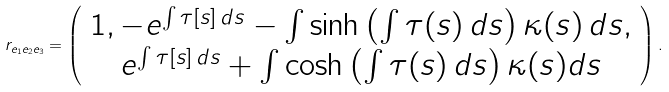Convert formula to latex. <formula><loc_0><loc_0><loc_500><loc_500>r _ { e _ { 1 } e _ { 2 } e _ { 3 } } = \left ( \begin{array} { c } 1 , - e ^ { \int \tau [ s ] \, d s } - \int \sinh \left ( \int \tau ( s ) \, d s \right ) \kappa ( s ) \, d s , \\ e ^ { \int \tau [ s ] \, d s } + \int \cosh \left ( \int \tau ( s ) \, d s \right ) \kappa ( s ) d s \end{array} \right ) .</formula> 